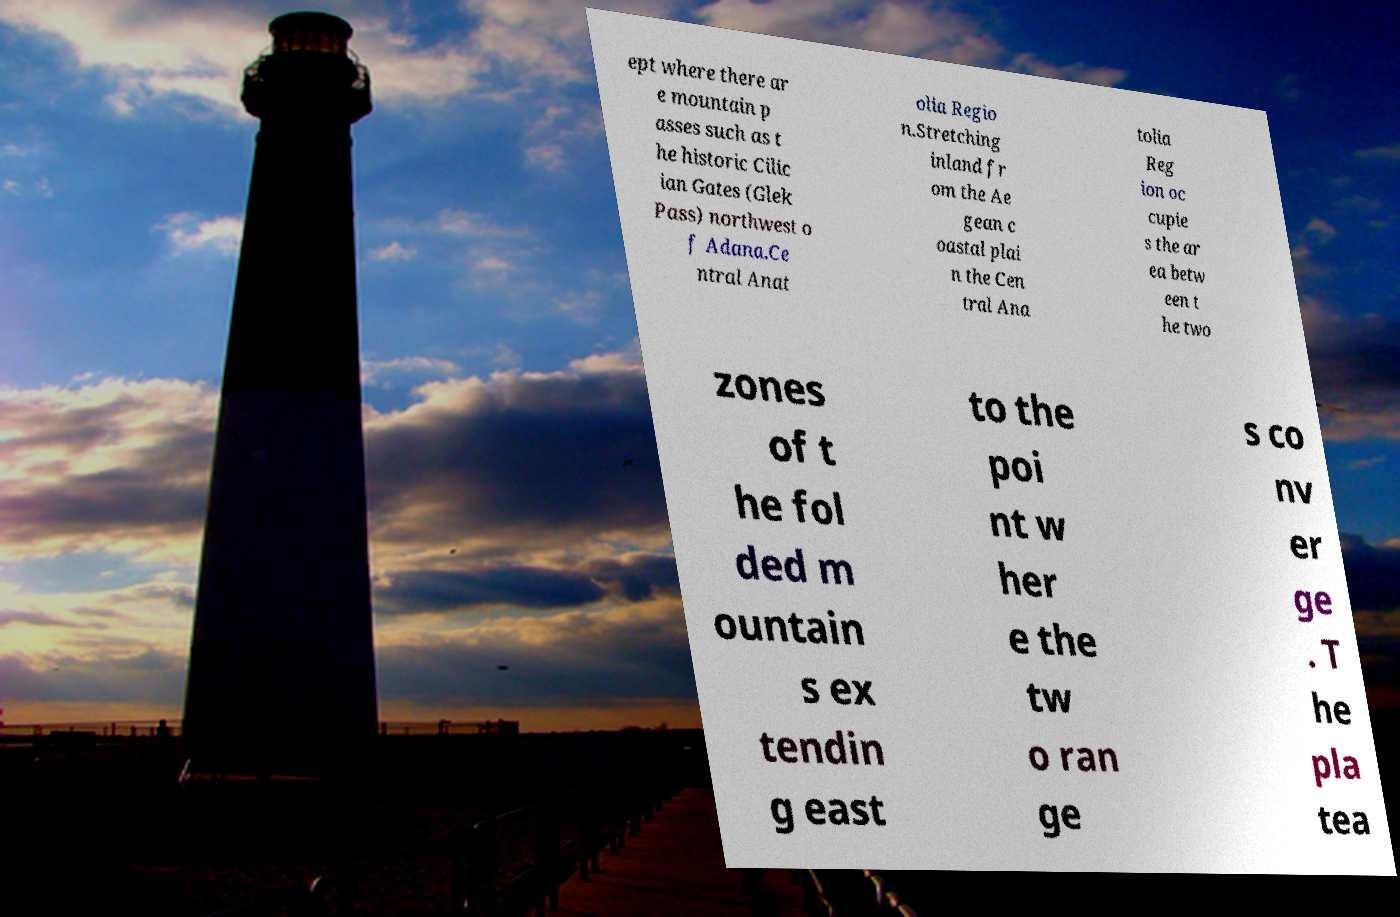Please read and relay the text visible in this image. What does it say? ept where there ar e mountain p asses such as t he historic Cilic ian Gates (Glek Pass) northwest o f Adana.Ce ntral Anat olia Regio n.Stretching inland fr om the Ae gean c oastal plai n the Cen tral Ana tolia Reg ion oc cupie s the ar ea betw een t he two zones of t he fol ded m ountain s ex tendin g east to the poi nt w her e the tw o ran ge s co nv er ge . T he pla tea 